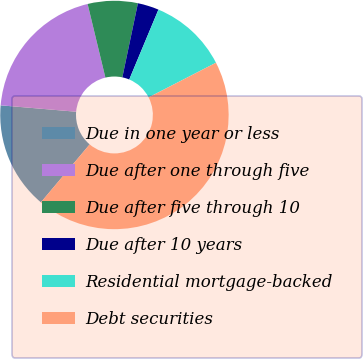Convert chart. <chart><loc_0><loc_0><loc_500><loc_500><pie_chart><fcel>Due in one year or less<fcel>Due after one through five<fcel>Due after five through 10<fcel>Due after 10 years<fcel>Residential mortgage-backed<fcel>Debt securities<nl><fcel>15.21%<fcel>19.88%<fcel>7.07%<fcel>3.0%<fcel>11.14%<fcel>43.7%<nl></chart> 